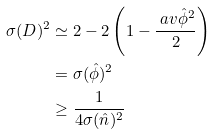<formula> <loc_0><loc_0><loc_500><loc_500>\sigma ( D ) ^ { 2 } & \simeq 2 - 2 \left ( 1 - \frac { \ a v { \hat { \phi } ^ { 2 } } } { 2 } \right ) \\ & = \sigma ( \hat { \phi } ) ^ { 2 } \\ & \geq \frac { 1 } { 4 \sigma ( \hat { n } ) ^ { 2 } }</formula> 